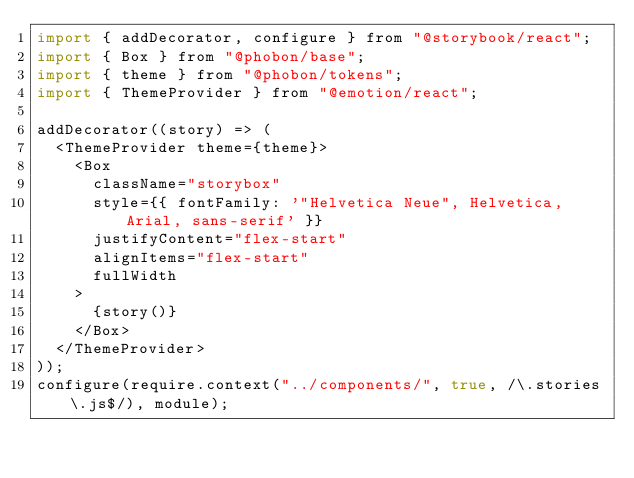<code> <loc_0><loc_0><loc_500><loc_500><_JavaScript_>import { addDecorator, configure } from "@storybook/react";
import { Box } from "@phobon/base";
import { theme } from "@phobon/tokens";
import { ThemeProvider } from "@emotion/react";

addDecorator((story) => (
  <ThemeProvider theme={theme}>
    <Box
      className="storybox"
      style={{ fontFamily: '"Helvetica Neue", Helvetica, Arial, sans-serif' }}
      justifyContent="flex-start"
      alignItems="flex-start"
      fullWidth
    >
      {story()}
    </Box>
  </ThemeProvider>
));
configure(require.context("../components/", true, /\.stories\.js$/), module);
</code> 